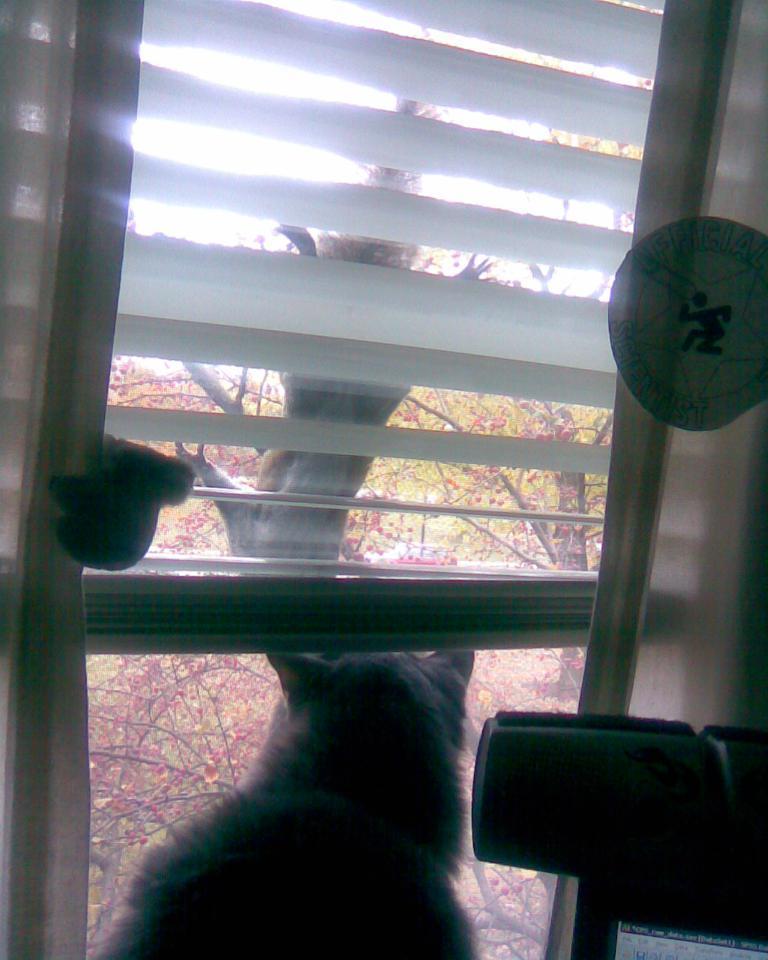In one or two sentences, can you explain what this image depicts? In this image cat viewing from the window. At the background there are trees. 